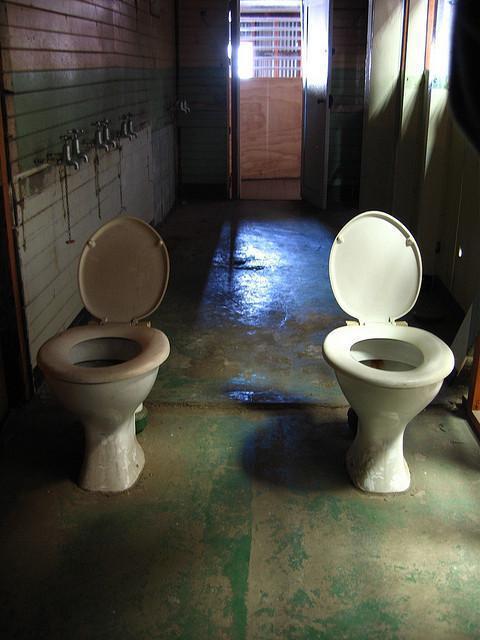How many toilets have the lid open?
Give a very brief answer. 2. How many toilets are there?
Give a very brief answer. 2. 